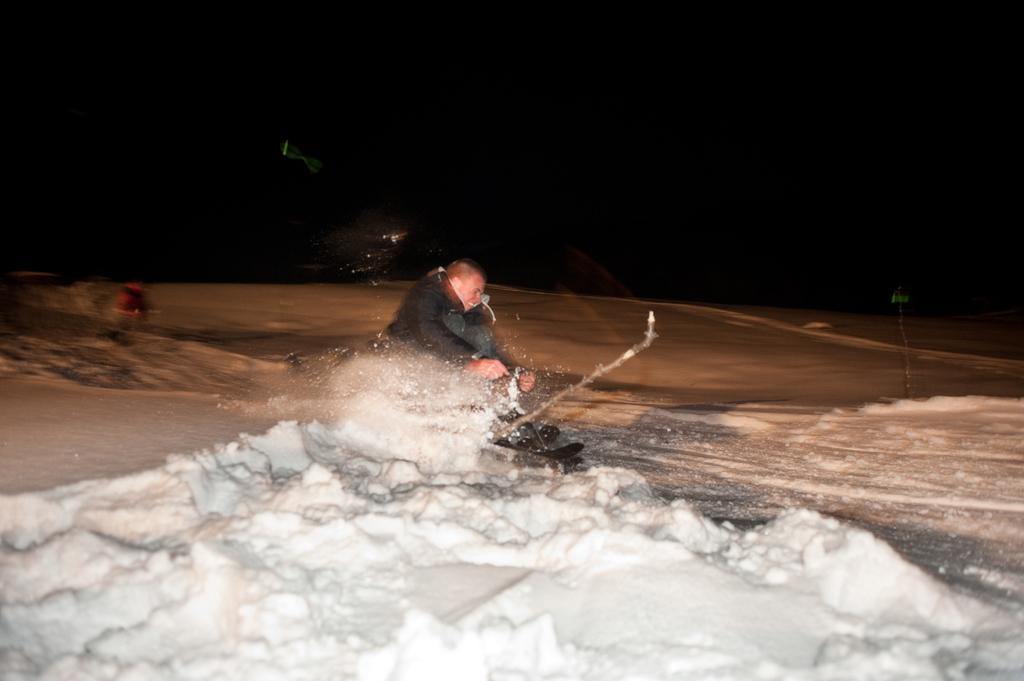What is the main activity of the person in the image? The person in the image is skiing. What type of terrain is the skiing taking place on? The skiing is taking place on snow. Can you describe the background of the image? The background of the image is dark. Are there any other people visible in the image? Yes, there is another person visible in the background on the snow. What type of kite is the person flying in the image? There is no kite present in the image; the person is skiing on snow. Are there any bears visible in the image? No, there are no bears present in the image. 